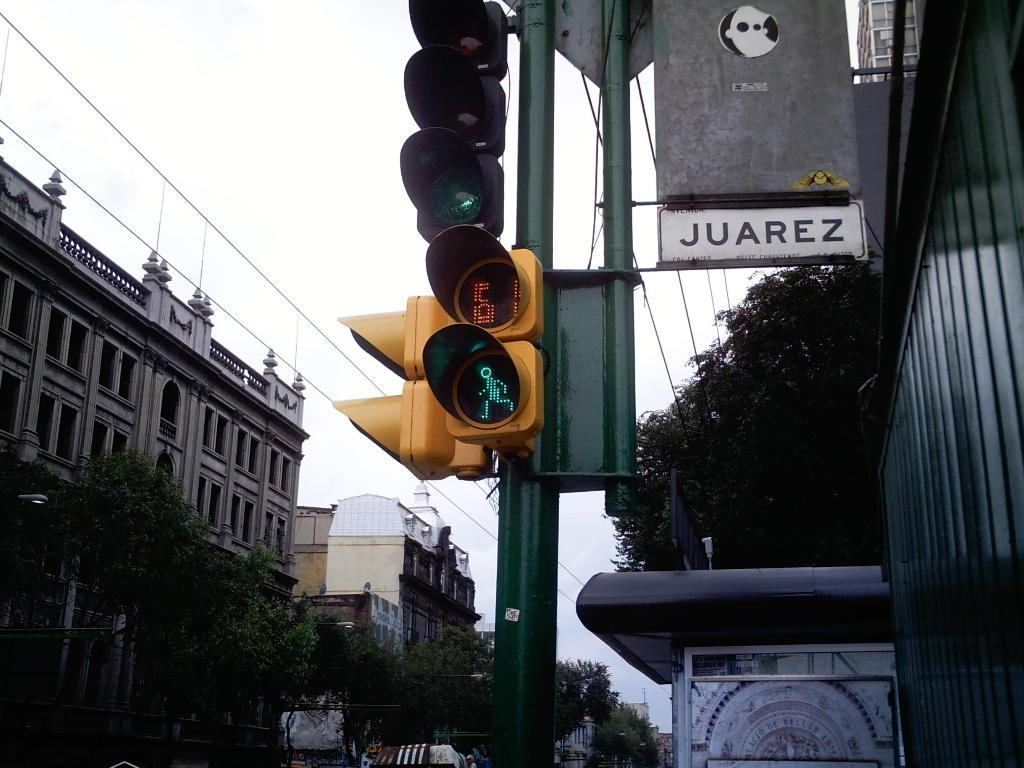<image>
Describe the image concisely. A traffic control light on a city street corner with other buildings and signs  lining the business fronts with on that says JUAREZ. 